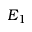<formula> <loc_0><loc_0><loc_500><loc_500>E _ { 1 }</formula> 